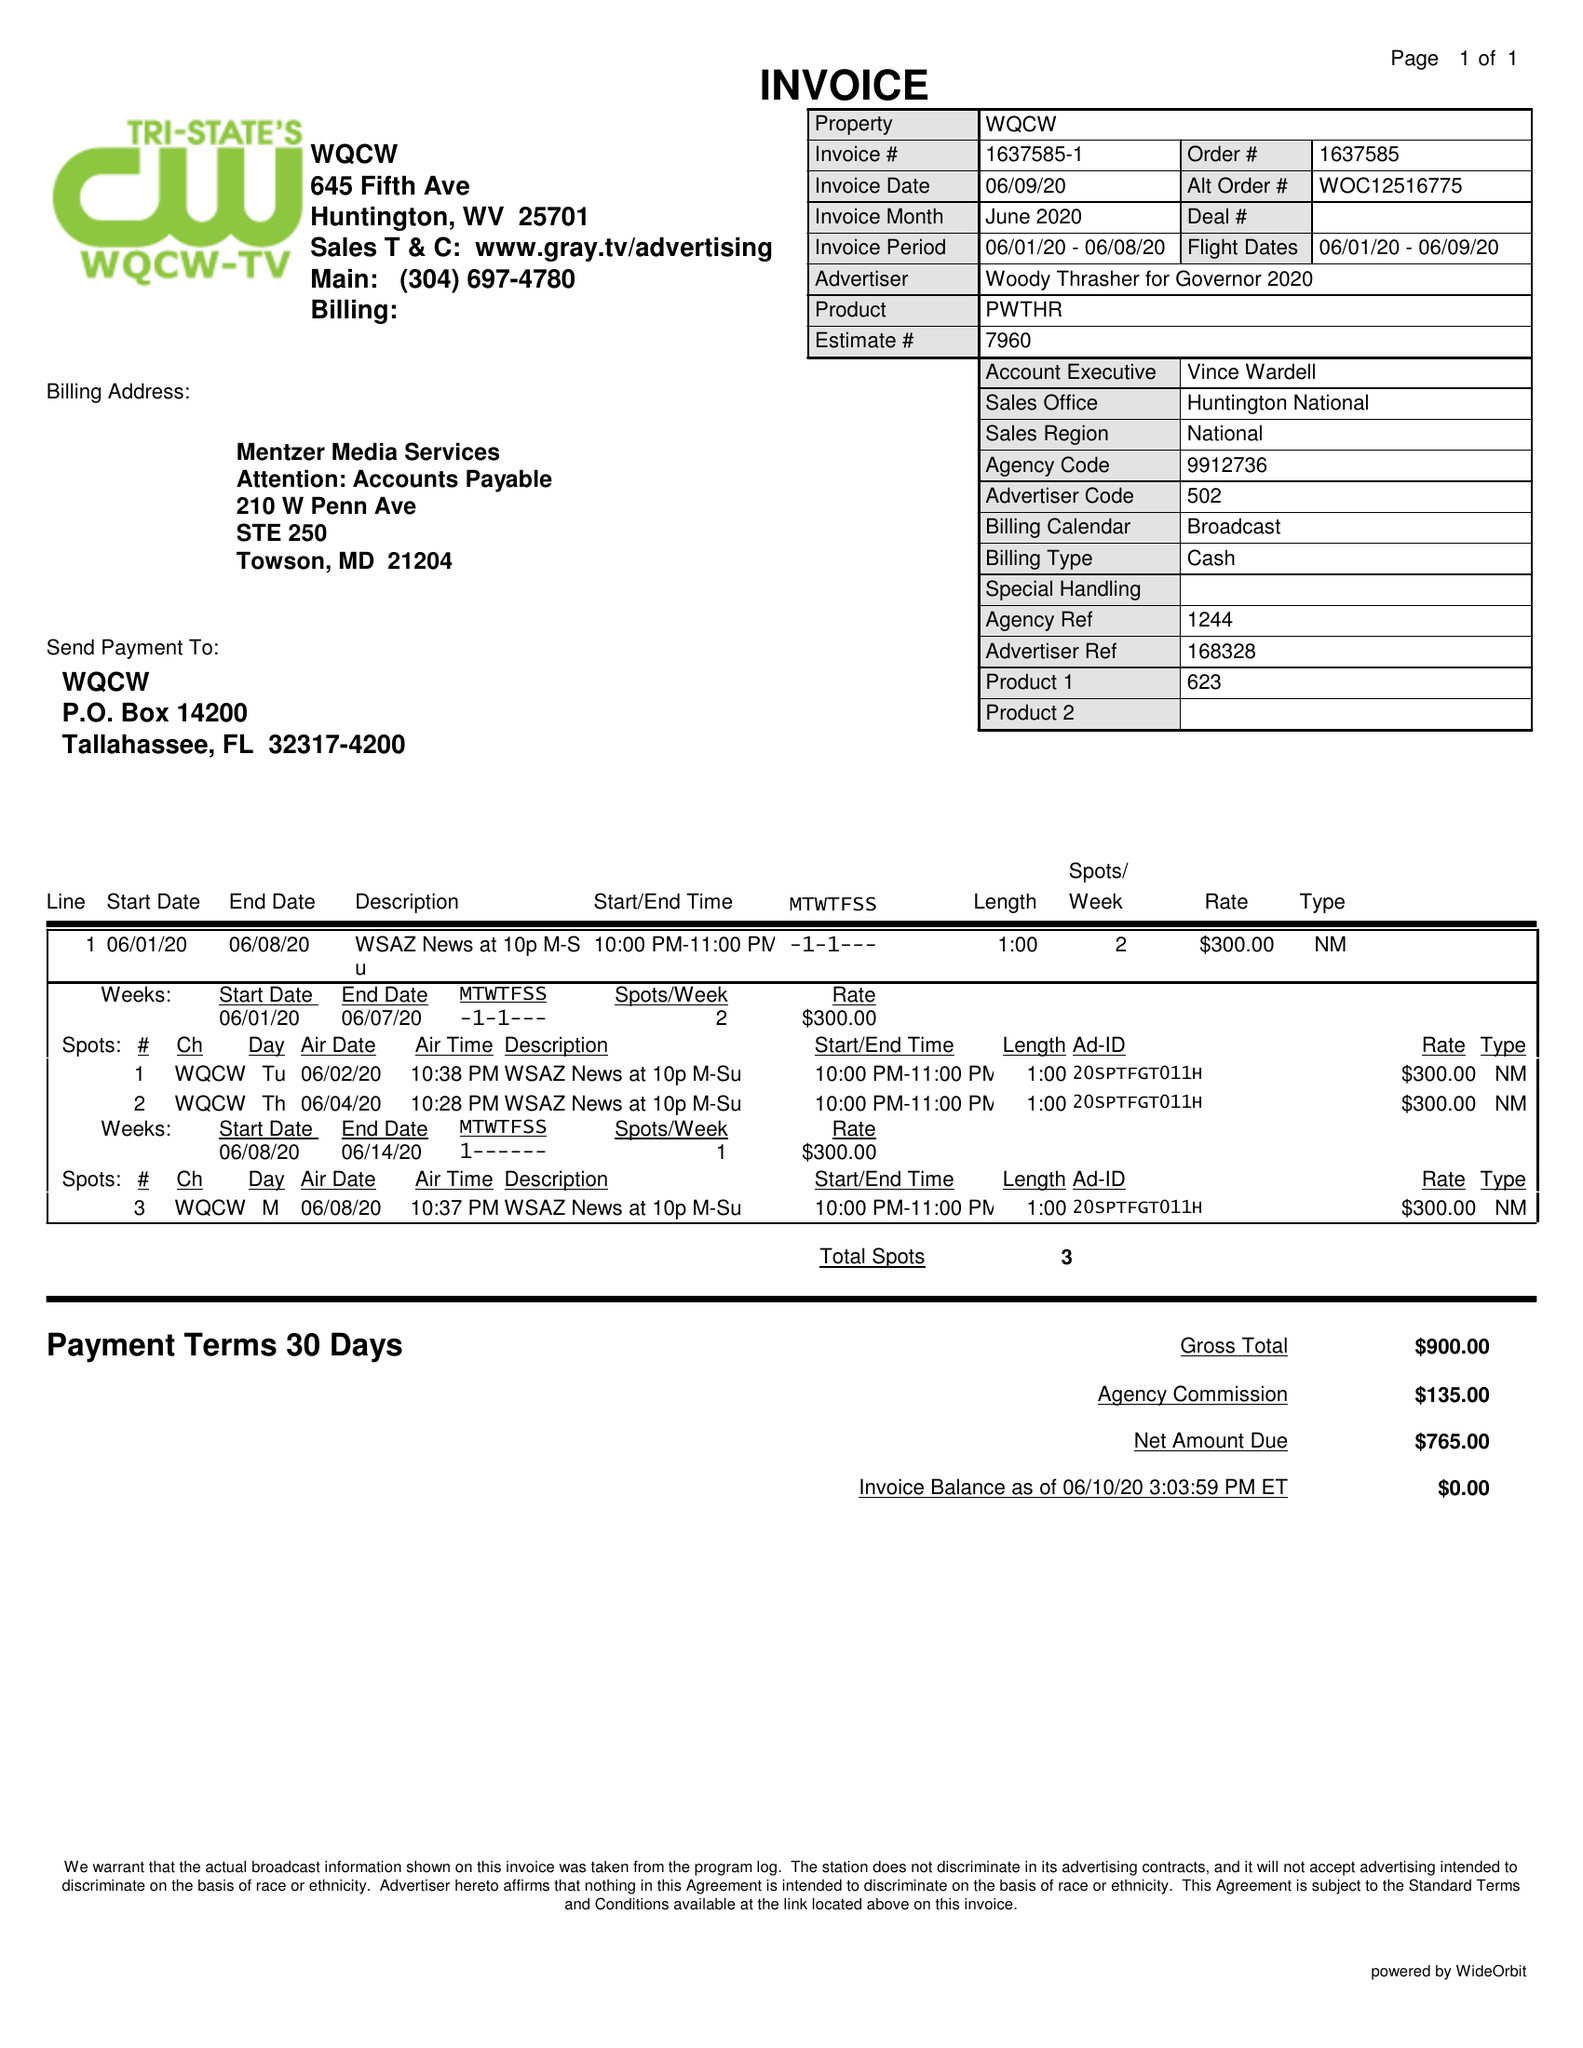What is the value for the advertiser?
Answer the question using a single word or phrase. WOODY THRASHER FOR GOVERNOR 2020 